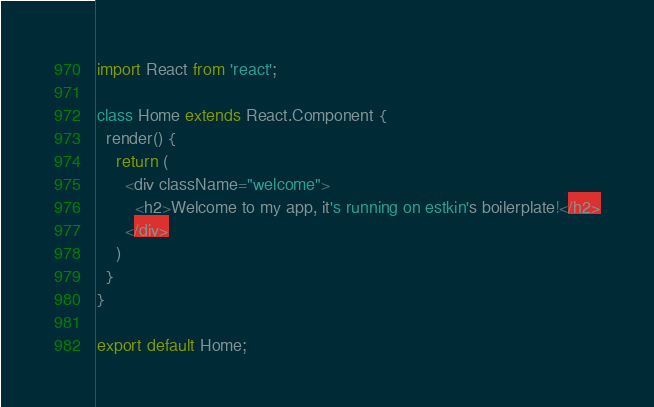Convert code to text. <code><loc_0><loc_0><loc_500><loc_500><_JavaScript_>import React from 'react';

class Home extends React.Component {
  render() {
    return (
      <div className="welcome">
        <h2>Welcome to my app, it's running on estkin's boilerplate!</h2>
      </div>
    )
  }
}

export default Home;
</code> 